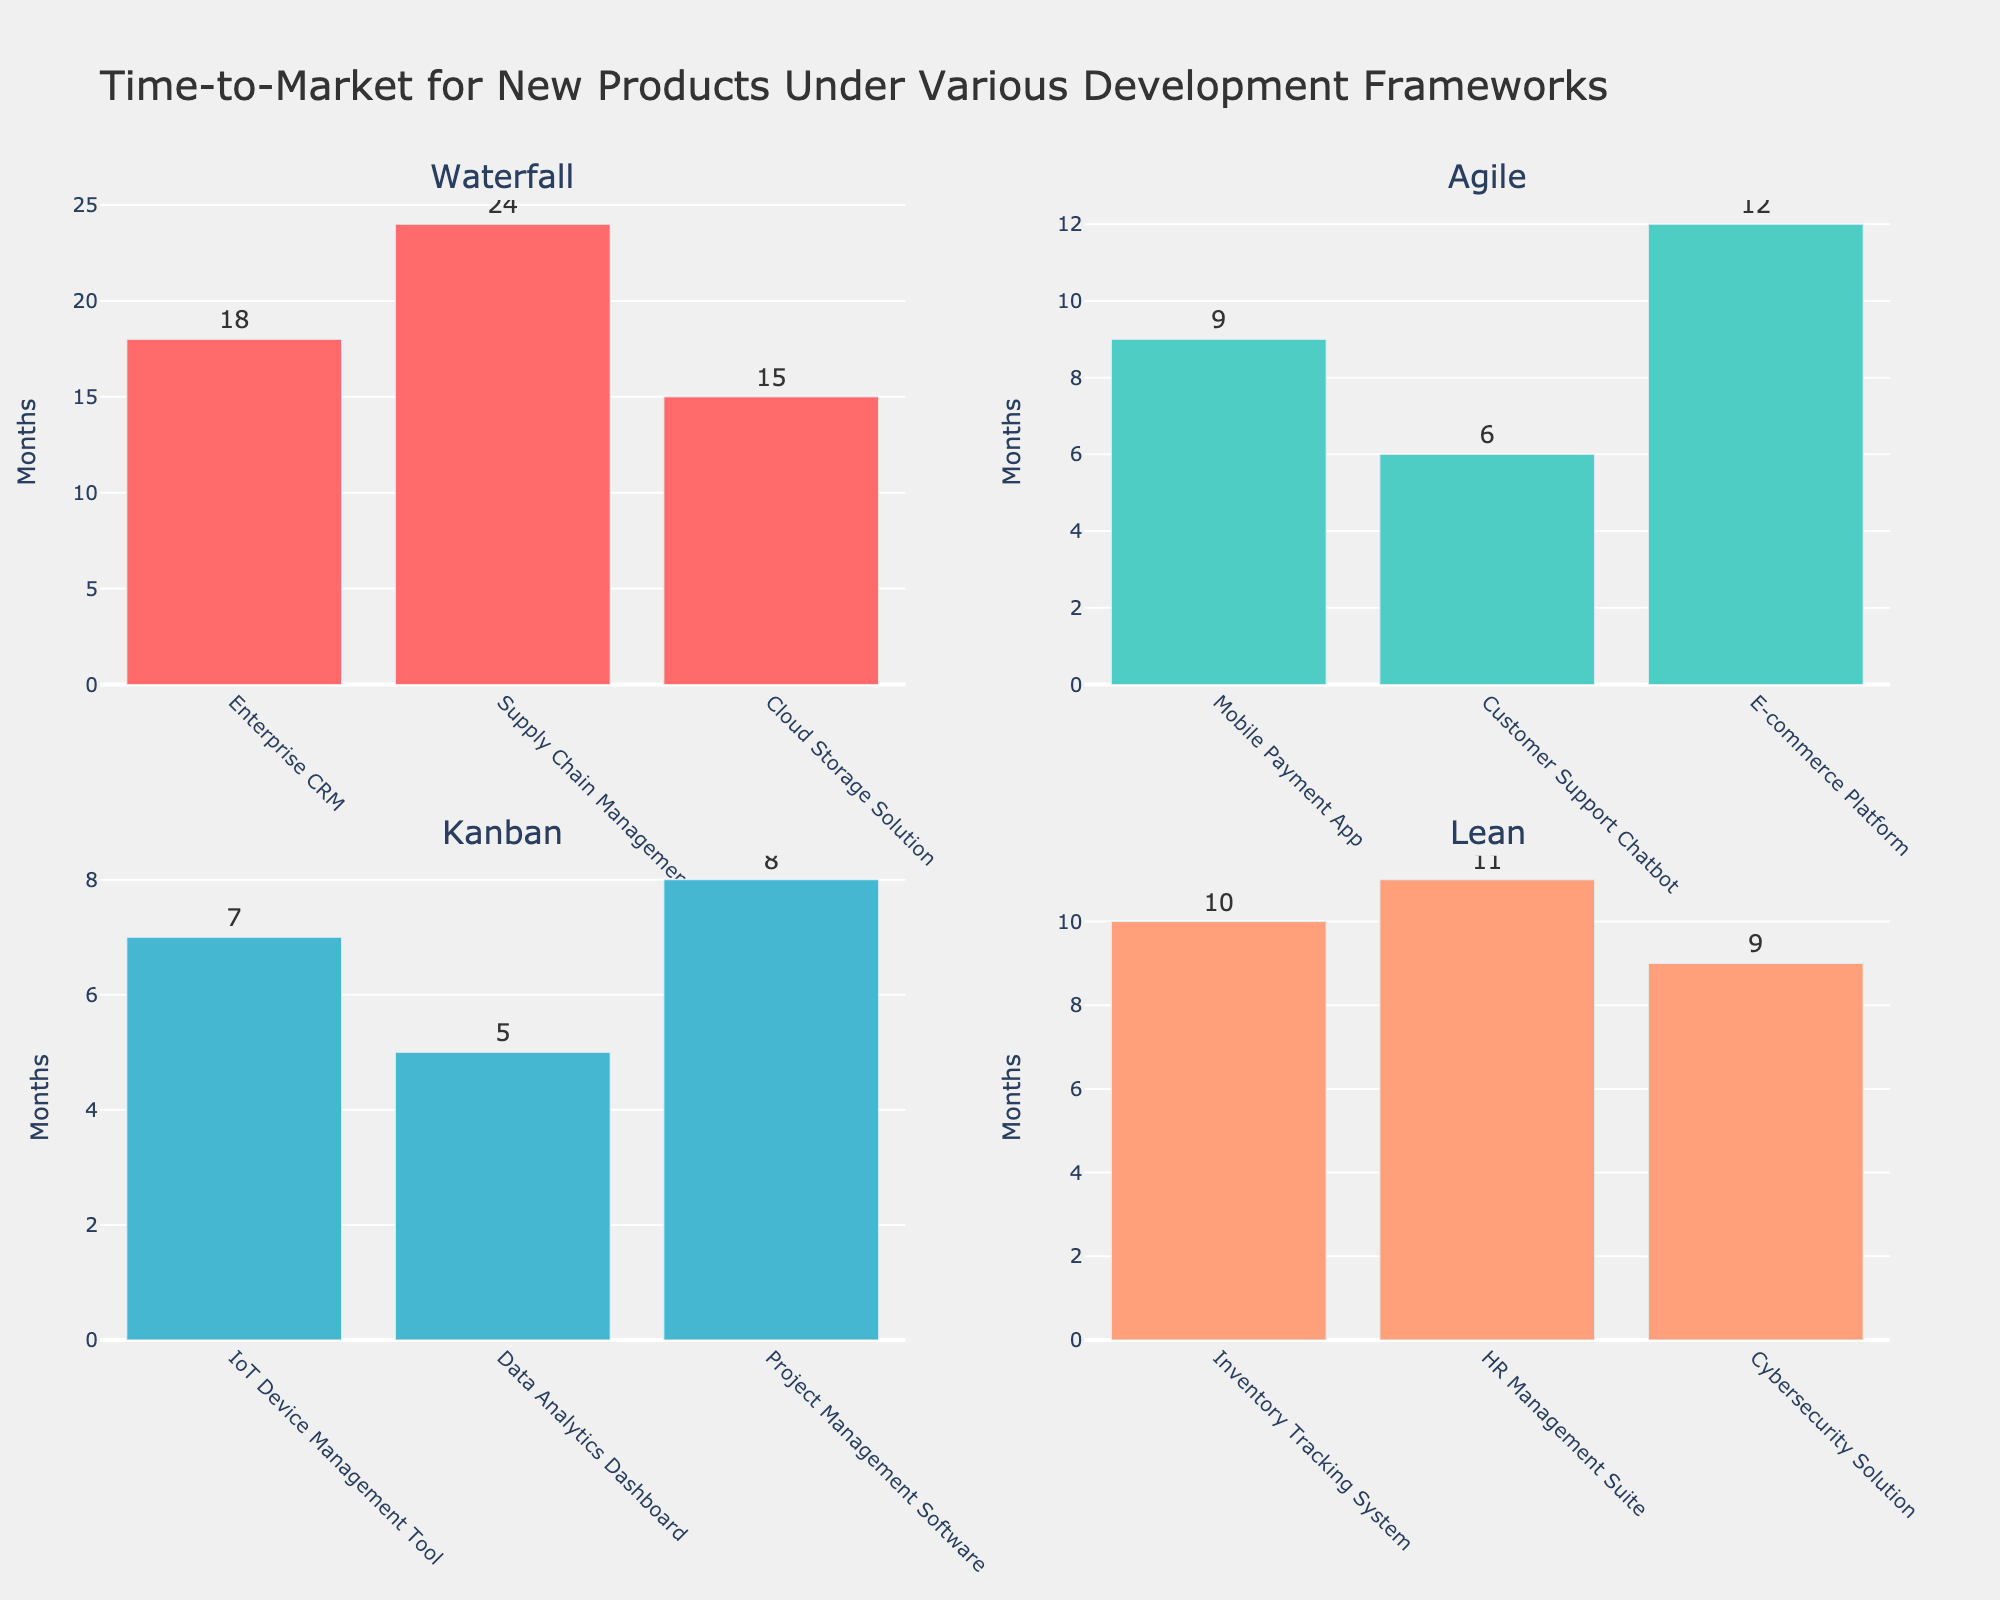How many products are associated with each framework? To find the number of products for each framework, look at the bars in each subplot. Count the bars in the Waterfall, Agile, Kanban, and Lean subplots respectively.
Answer: Waterfall: 3, Agile: 3, Kanban: 3, Lean: 3 Which product has the shortest time-to-market in the Agile framework? Refer to the Agile subplot. Identify the bar with the lowest height, which represents the shortest time-to-market. The product label on the x-axis of this bar is the name of the product.
Answer: Customer Support Chatbot What is the average time-to-market for products developed using the Kanban framework? Calculate the average of the months for the Kanban framework. Add the months for the IoT Device Management Tool (7), Data Analytics Dashboard (5), and Project Management Software (8). Then, divide the sum by the number of products (3). (7+5+8)/3 = 6.67 months.
Answer: 6.67 months Among the presented frameworks, which one has the longest time-to-market for a single product? Look at each subplot to identify the bar with the greatest height, which represents the longest time-to-market. Compare the highest bars from Waterfall, Agile, Kanban, and Lean subplots.
Answer: Waterfall (Supply Chain Management System) Which product in the Lean framework has the shortest time-to-market and what is its duration? Refer to the Lean subplot. Identify the shortest bar in this framework, which represents the shortest time-to-market. The x-axis label on this bar is the product name, and the y-axis value is its duration.
Answer: Cybersecurity Solution, 9 Months 